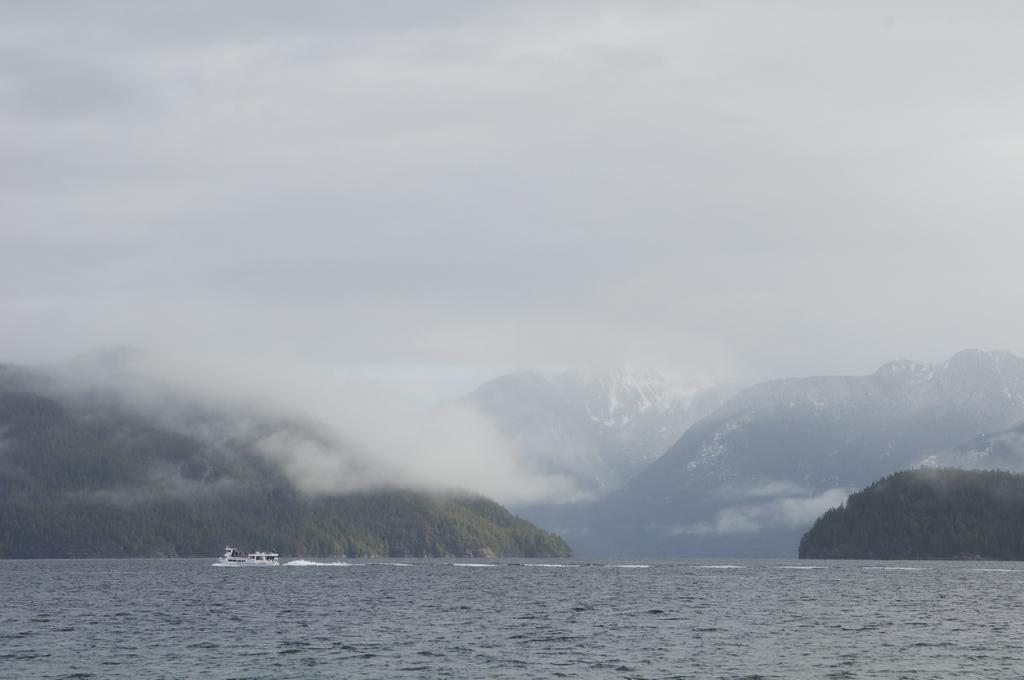What is the main subject of the image? The main subject of the image is a boat. Can you describe the boat's position in relation to the water? The boat is above the water in the image. What can be seen in the background of the image? There are trees, mountains, fog, and the sky visible in the background of the image. What type of paste is being used to divide the beans in the image? There is no paste or beans present in the image; it features a boat above the water with a background of trees, mountains, fog, and the sky. 